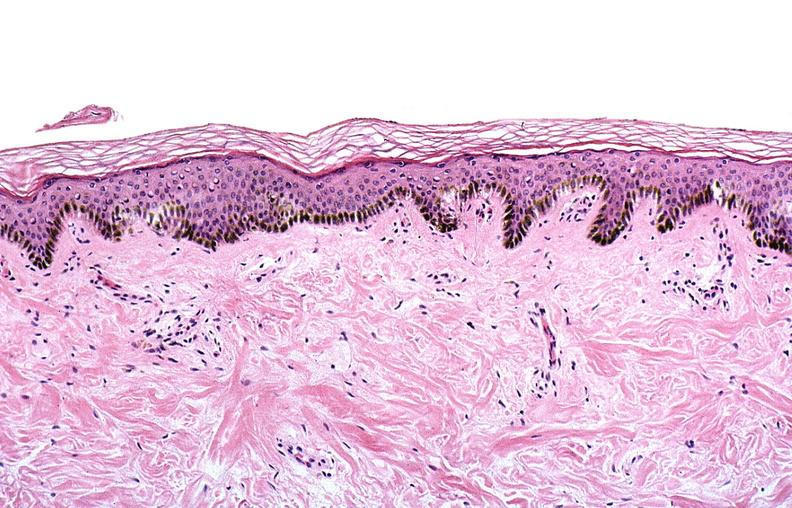what does this image show?
Answer the question using a single word or phrase. Thermal burned skin 